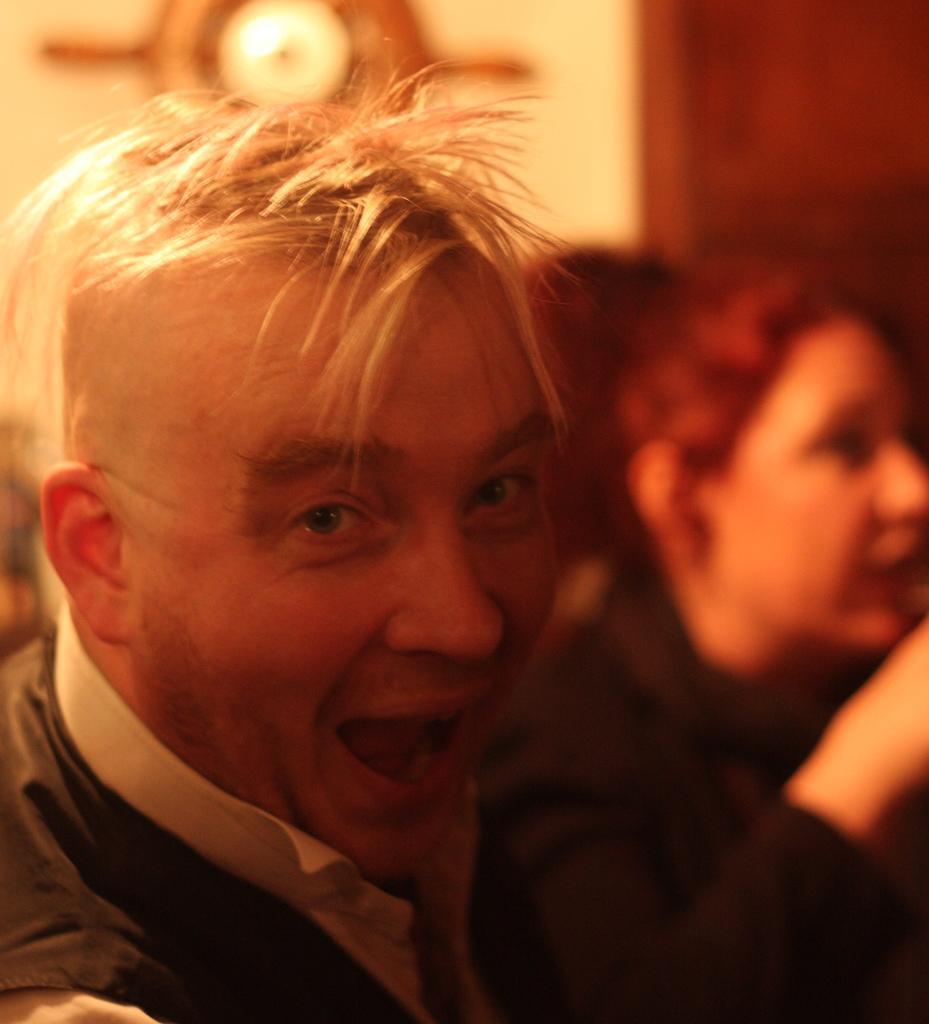Describe this image in one or two sentences. In this image there is a man , and there is blur background. 